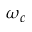<formula> <loc_0><loc_0><loc_500><loc_500>\omega _ { c }</formula> 